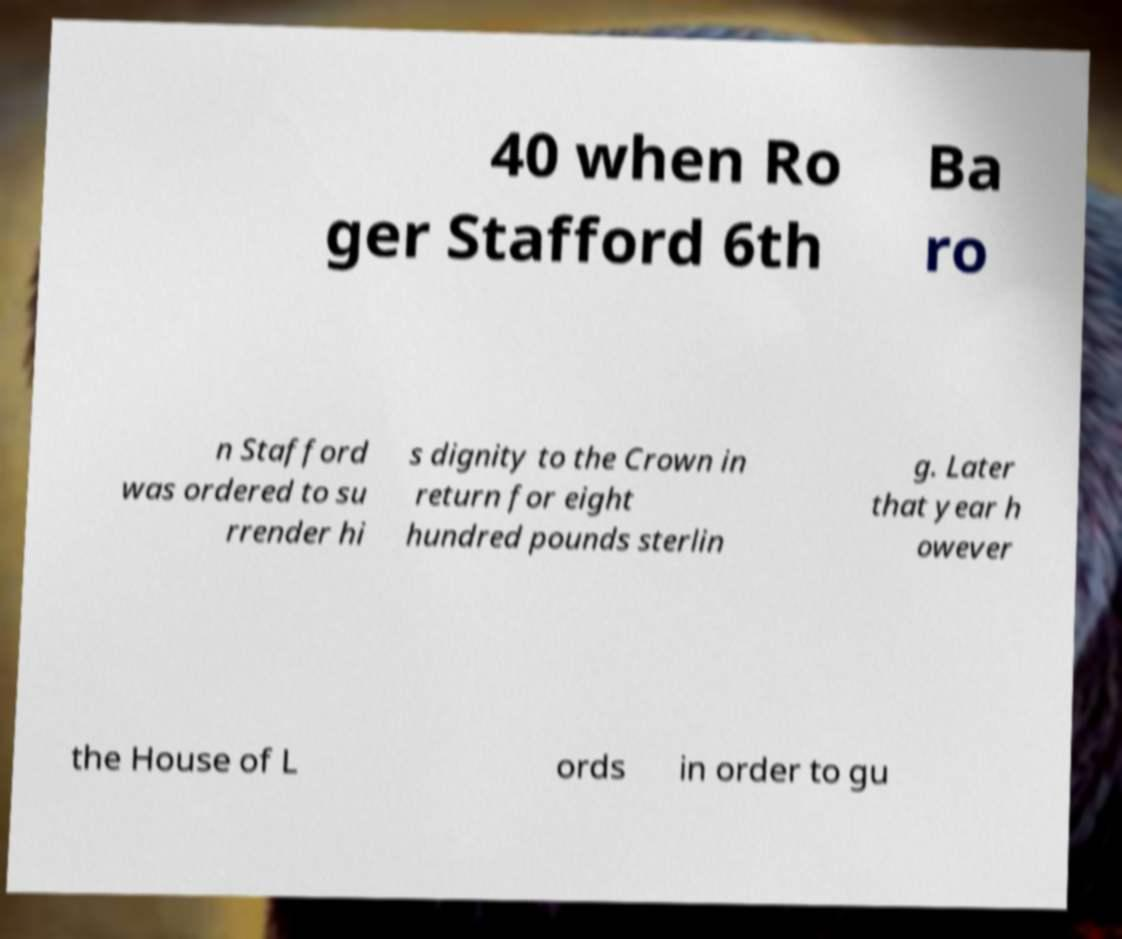For documentation purposes, I need the text within this image transcribed. Could you provide that? 40 when Ro ger Stafford 6th Ba ro n Stafford was ordered to su rrender hi s dignity to the Crown in return for eight hundred pounds sterlin g. Later that year h owever the House of L ords in order to gu 